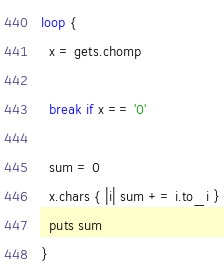<code> <loc_0><loc_0><loc_500><loc_500><_Ruby_>loop {
  x = gets.chomp

  break if x == '0'

  sum = 0
  x.chars { |i| sum += i.to_i }
  puts sum
}</code> 